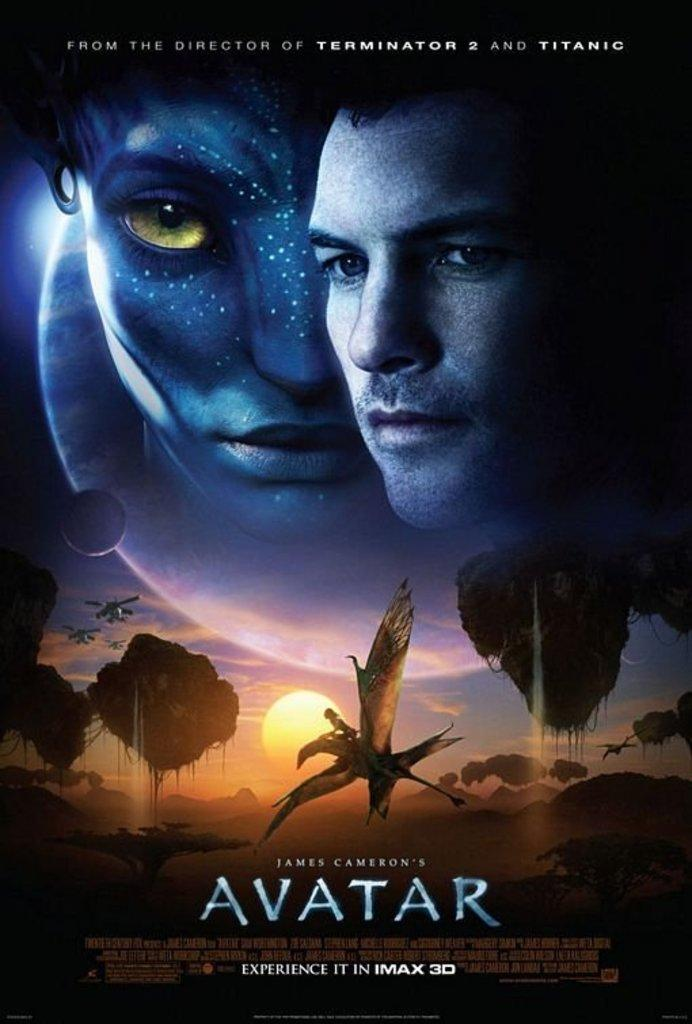<image>
Write a terse but informative summary of the picture. A poster for the movie Avatar shows a man and and bird flying in the sky 